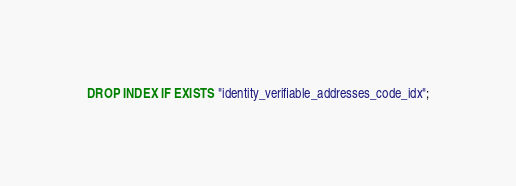<code> <loc_0><loc_0><loc_500><loc_500><_SQL_>DROP INDEX IF EXISTS "identity_verifiable_addresses_code_idx";</code> 